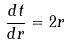<formula> <loc_0><loc_0><loc_500><loc_500>\frac { d t } { d r } = 2 r</formula> 